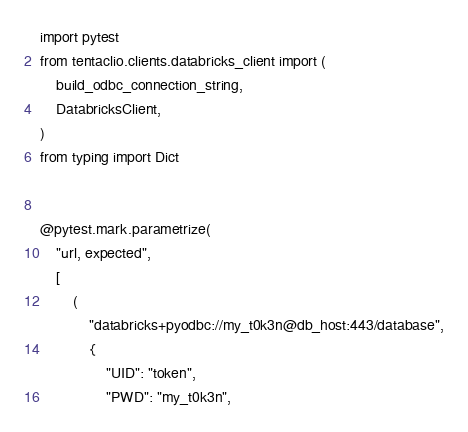Convert code to text. <code><loc_0><loc_0><loc_500><loc_500><_Python_>import pytest
from tentaclio.clients.databricks_client import (
    build_odbc_connection_string,
    DatabricksClient,
)
from typing import Dict


@pytest.mark.parametrize(
    "url, expected",
    [
        (
            "databricks+pyodbc://my_t0k3n@db_host:443/database",
            {
                "UID": "token",
                "PWD": "my_t0k3n",</code> 